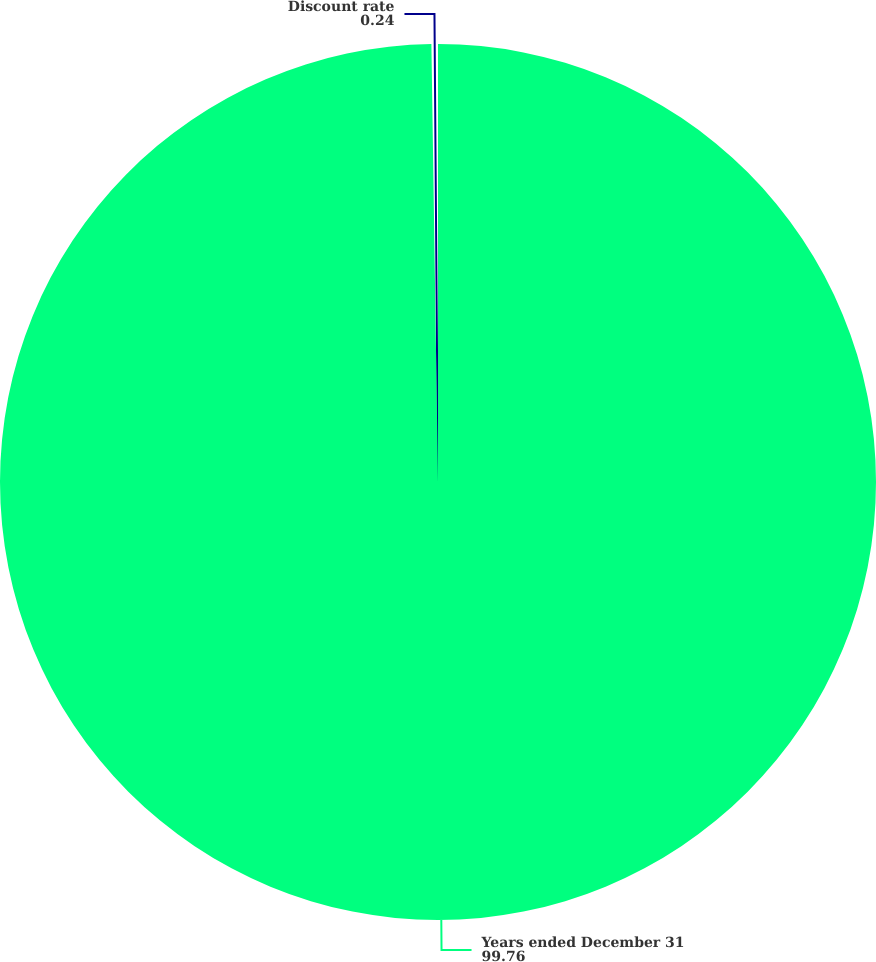Convert chart. <chart><loc_0><loc_0><loc_500><loc_500><pie_chart><fcel>Years ended December 31<fcel>Discount rate<nl><fcel>99.76%<fcel>0.24%<nl></chart> 